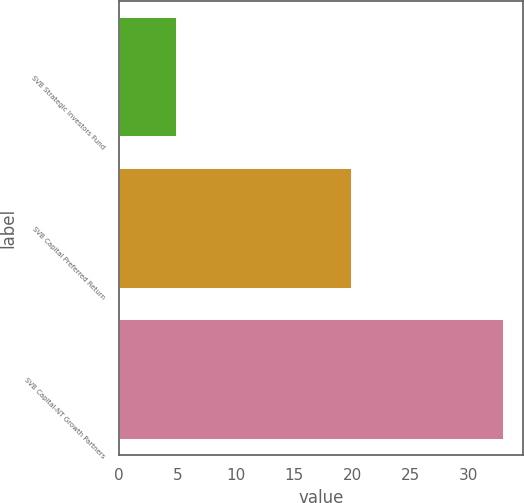Convert chart. <chart><loc_0><loc_0><loc_500><loc_500><bar_chart><fcel>SVB Strategic Investors Fund<fcel>SVB Capital Preferred Return<fcel>SVB Capital-NT Growth Partners<nl><fcel>5<fcel>20<fcel>33<nl></chart> 